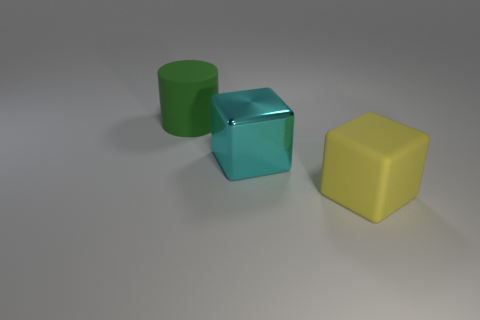What number of other rubber cubes are the same color as the big rubber cube?
Give a very brief answer. 0. Does the big matte thing behind the big yellow rubber object have the same color as the thing right of the cyan thing?
Your answer should be compact. No. There is a metal block; are there any large yellow things on the right side of it?
Your answer should be very brief. Yes. What is the large cyan block made of?
Give a very brief answer. Metal. What shape is the large rubber thing on the right side of the large green matte cylinder?
Provide a succinct answer. Cube. Is there a cyan thing of the same size as the cylinder?
Provide a short and direct response. Yes. Is the material of the block to the left of the yellow cube the same as the green cylinder?
Offer a very short reply. No. Are there an equal number of large green rubber things that are on the right side of the big metallic object and rubber cubes that are in front of the yellow matte cube?
Your answer should be compact. Yes. There is a big thing that is to the right of the green thing and on the left side of the matte cube; what shape is it?
Ensure brevity in your answer.  Cube. What number of big rubber things are behind the cyan object?
Make the answer very short. 1. 